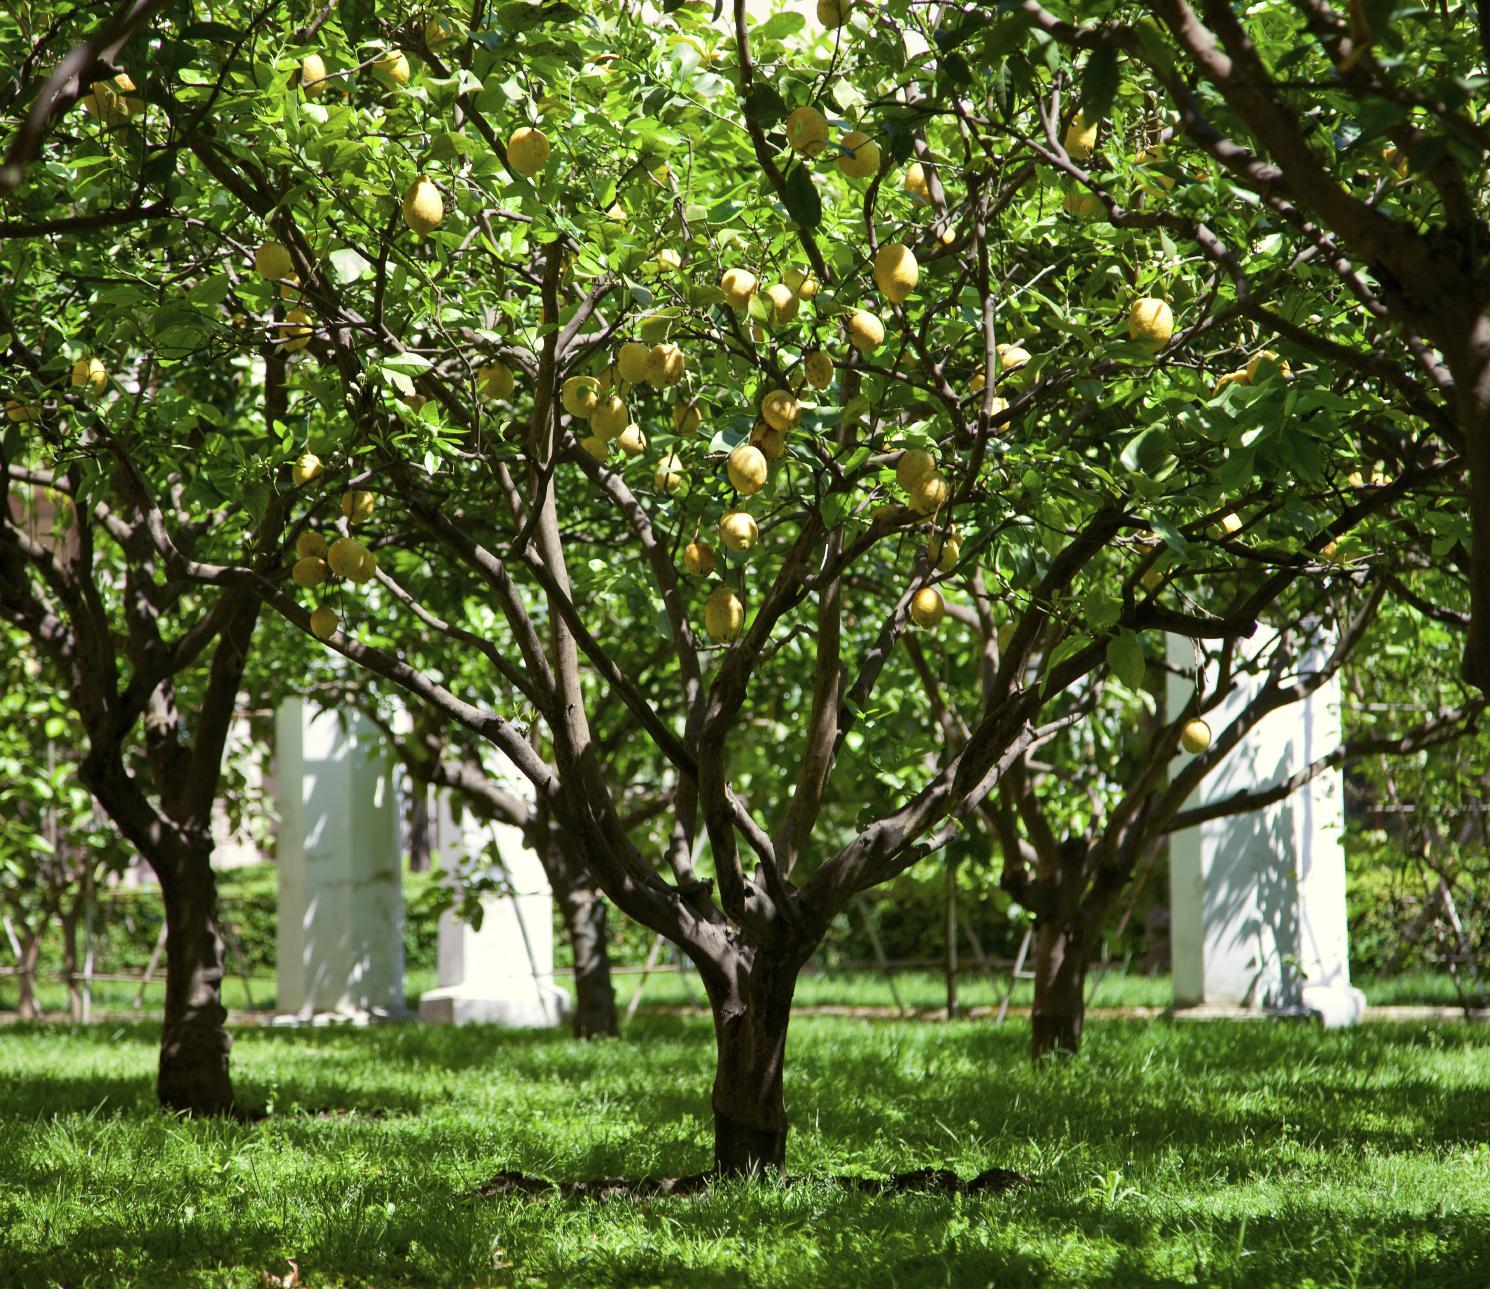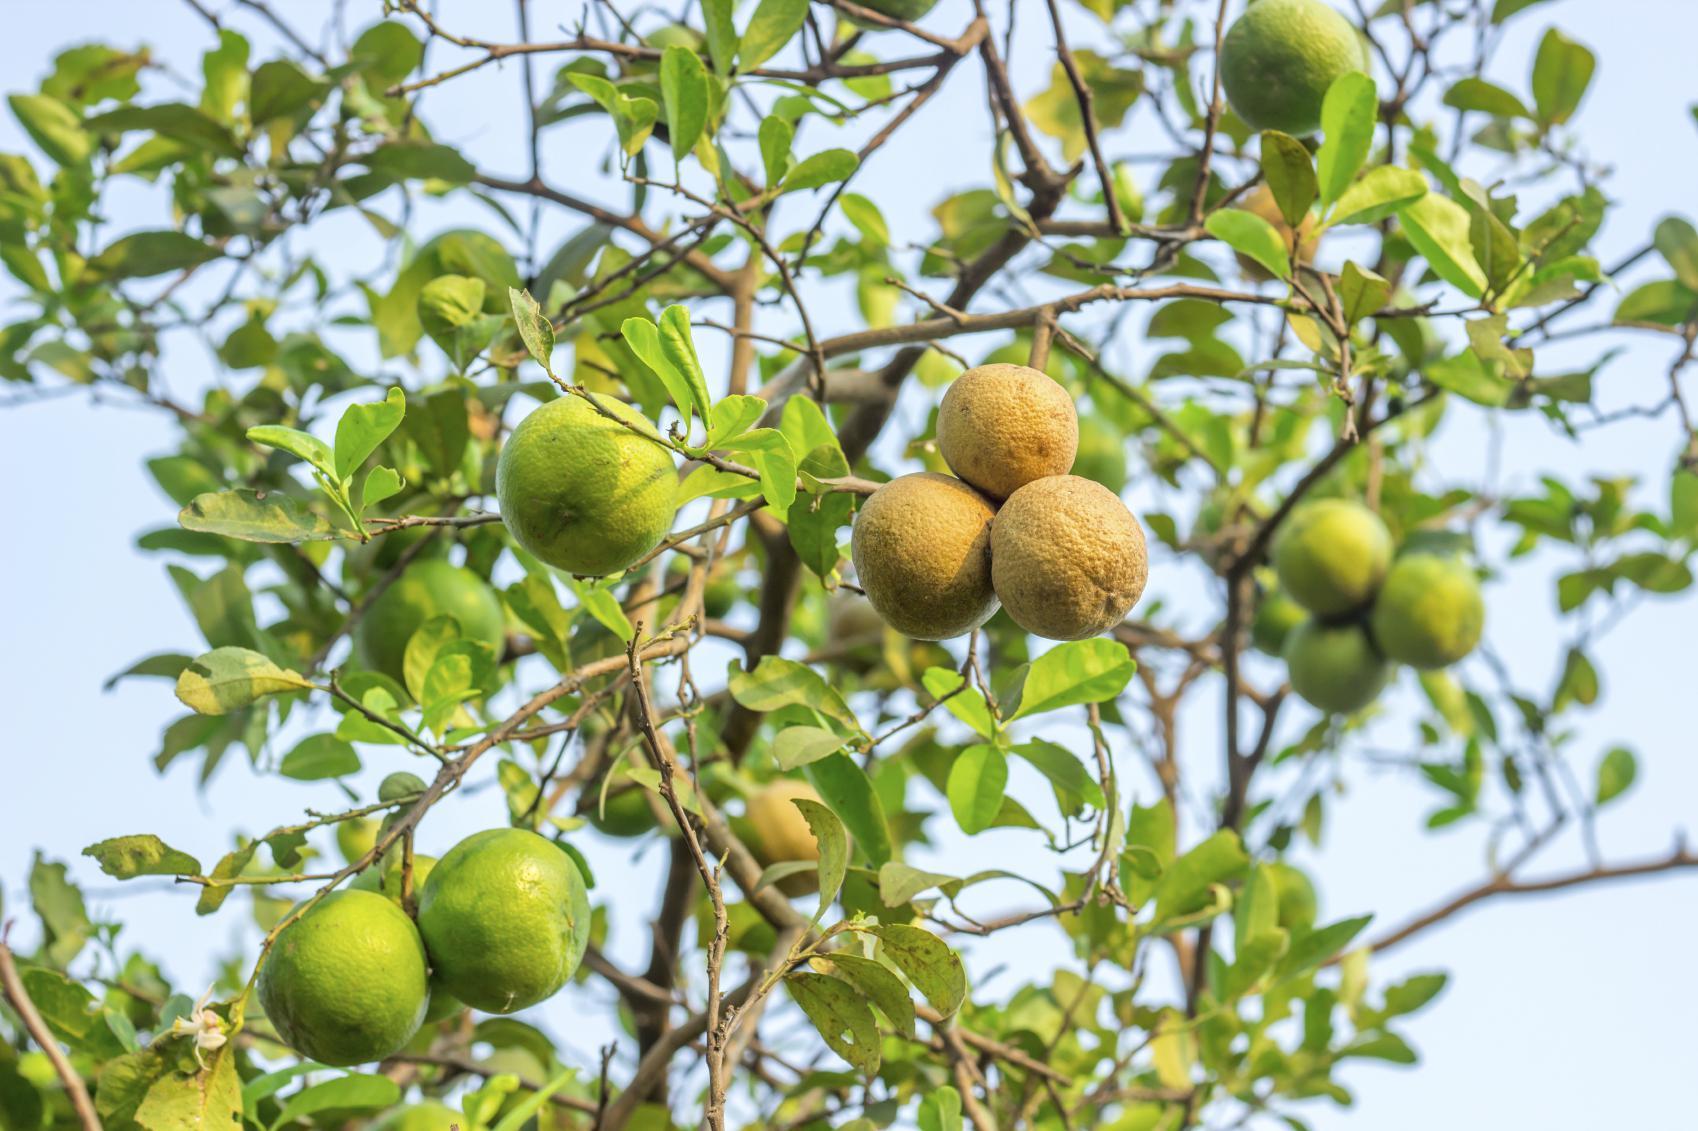The first image is the image on the left, the second image is the image on the right. Evaluate the accuracy of this statement regarding the images: "The right image contains no more than three lemons.". Is it true? Answer yes or no. No. The first image is the image on the left, the second image is the image on the right. For the images shown, is this caption "One image contains only two whole lemons with peels intact." true? Answer yes or no. No. 